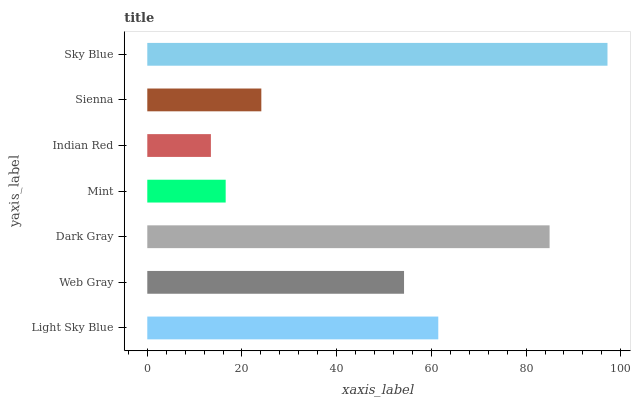Is Indian Red the minimum?
Answer yes or no. Yes. Is Sky Blue the maximum?
Answer yes or no. Yes. Is Web Gray the minimum?
Answer yes or no. No. Is Web Gray the maximum?
Answer yes or no. No. Is Light Sky Blue greater than Web Gray?
Answer yes or no. Yes. Is Web Gray less than Light Sky Blue?
Answer yes or no. Yes. Is Web Gray greater than Light Sky Blue?
Answer yes or no. No. Is Light Sky Blue less than Web Gray?
Answer yes or no. No. Is Web Gray the high median?
Answer yes or no. Yes. Is Web Gray the low median?
Answer yes or no. Yes. Is Sienna the high median?
Answer yes or no. No. Is Mint the low median?
Answer yes or no. No. 